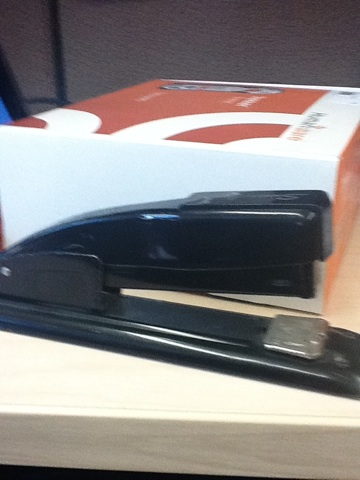Can you tell me more about what is in this image? Certainly! The image shows a black stapler placed on a table, with what appears to be a box of printer paper in the background. The stapler is a standard desktop model commonly used in offices and homes. How does a stapler work? A stapler works by forcing a metal staple through sheets of paper placed beneath its head. When you press down on the top, a hammer inside the stapler pushes the staple through the paper and against a metal plate that bends the staple’s ends inward, securing the sheets together. To use it, you insert a stack of paper, press down on the top of the stapler, and the staple is driven through the paper. 